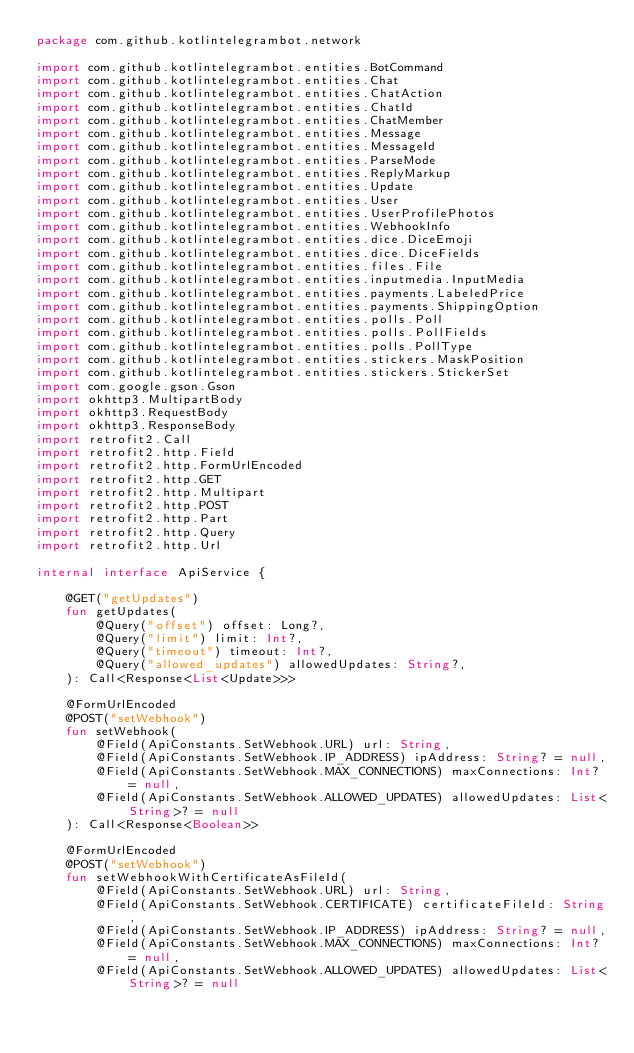Convert code to text. <code><loc_0><loc_0><loc_500><loc_500><_Kotlin_>package com.github.kotlintelegrambot.network

import com.github.kotlintelegrambot.entities.BotCommand
import com.github.kotlintelegrambot.entities.Chat
import com.github.kotlintelegrambot.entities.ChatAction
import com.github.kotlintelegrambot.entities.ChatId
import com.github.kotlintelegrambot.entities.ChatMember
import com.github.kotlintelegrambot.entities.Message
import com.github.kotlintelegrambot.entities.MessageId
import com.github.kotlintelegrambot.entities.ParseMode
import com.github.kotlintelegrambot.entities.ReplyMarkup
import com.github.kotlintelegrambot.entities.Update
import com.github.kotlintelegrambot.entities.User
import com.github.kotlintelegrambot.entities.UserProfilePhotos
import com.github.kotlintelegrambot.entities.WebhookInfo
import com.github.kotlintelegrambot.entities.dice.DiceEmoji
import com.github.kotlintelegrambot.entities.dice.DiceFields
import com.github.kotlintelegrambot.entities.files.File
import com.github.kotlintelegrambot.entities.inputmedia.InputMedia
import com.github.kotlintelegrambot.entities.payments.LabeledPrice
import com.github.kotlintelegrambot.entities.payments.ShippingOption
import com.github.kotlintelegrambot.entities.polls.Poll
import com.github.kotlintelegrambot.entities.polls.PollFields
import com.github.kotlintelegrambot.entities.polls.PollType
import com.github.kotlintelegrambot.entities.stickers.MaskPosition
import com.github.kotlintelegrambot.entities.stickers.StickerSet
import com.google.gson.Gson
import okhttp3.MultipartBody
import okhttp3.RequestBody
import okhttp3.ResponseBody
import retrofit2.Call
import retrofit2.http.Field
import retrofit2.http.FormUrlEncoded
import retrofit2.http.GET
import retrofit2.http.Multipart
import retrofit2.http.POST
import retrofit2.http.Part
import retrofit2.http.Query
import retrofit2.http.Url

internal interface ApiService {

    @GET("getUpdates")
    fun getUpdates(
        @Query("offset") offset: Long?,
        @Query("limit") limit: Int?,
        @Query("timeout") timeout: Int?,
        @Query("allowed_updates") allowedUpdates: String?,
    ): Call<Response<List<Update>>>

    @FormUrlEncoded
    @POST("setWebhook")
    fun setWebhook(
        @Field(ApiConstants.SetWebhook.URL) url: String,
        @Field(ApiConstants.SetWebhook.IP_ADDRESS) ipAddress: String? = null,
        @Field(ApiConstants.SetWebhook.MAX_CONNECTIONS) maxConnections: Int? = null,
        @Field(ApiConstants.SetWebhook.ALLOWED_UPDATES) allowedUpdates: List<String>? = null
    ): Call<Response<Boolean>>

    @FormUrlEncoded
    @POST("setWebhook")
    fun setWebhookWithCertificateAsFileId(
        @Field(ApiConstants.SetWebhook.URL) url: String,
        @Field(ApiConstants.SetWebhook.CERTIFICATE) certificateFileId: String,
        @Field(ApiConstants.SetWebhook.IP_ADDRESS) ipAddress: String? = null,
        @Field(ApiConstants.SetWebhook.MAX_CONNECTIONS) maxConnections: Int? = null,
        @Field(ApiConstants.SetWebhook.ALLOWED_UPDATES) allowedUpdates: List<String>? = null</code> 